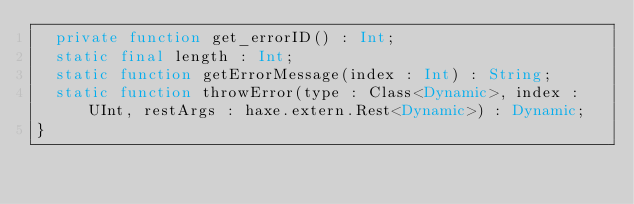<code> <loc_0><loc_0><loc_500><loc_500><_Haxe_>	private function get_errorID() : Int;
	static final length : Int;
	static function getErrorMessage(index : Int) : String;
	static function throwError(type : Class<Dynamic>, index : UInt, restArgs : haxe.extern.Rest<Dynamic>) : Dynamic;
}
</code> 